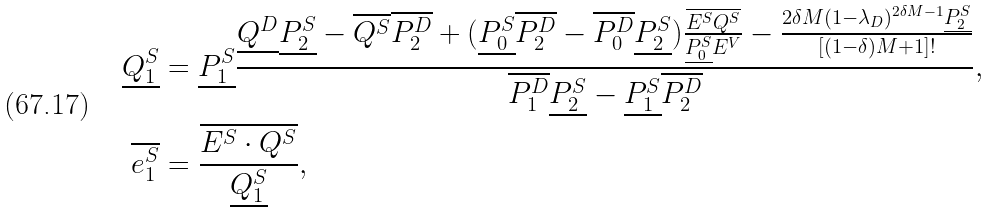Convert formula to latex. <formula><loc_0><loc_0><loc_500><loc_500>\underline { Q _ { 1 } ^ { S } } & = \underline { P _ { 1 } ^ { S } } \frac { \underline { Q ^ { D } } \underline { P _ { 2 } ^ { S } } - \overline { Q ^ { S } } \overline { P _ { 2 } ^ { D } } + ( \underline { P _ { 0 } ^ { S } } \overline { P _ { 2 } ^ { D } } - \overline { P _ { 0 } ^ { D } } \underline { P _ { 2 } ^ { S } } ) \frac { \overline { E ^ { S } Q ^ { S } } } { \underline { P _ { 0 } ^ { S } } E ^ { V } } - \frac { 2 \delta M ( 1 - \lambda _ { D } ) ^ { 2 \delta M - 1 } \underline { P _ { 2 } ^ { S } } } { [ ( 1 - \delta ) M + 1 ] ! } } { \overline { P _ { 1 } ^ { D } } \underline { P _ { 2 } ^ { S } } - \underline { P _ { 1 } ^ { S } } \overline { P _ { 2 } ^ { D } } } , \\ \overline { e _ { 1 } ^ { S } } & = \frac { \overline { E ^ { S } \cdot Q ^ { S } } } { \underline { Q _ { 1 } ^ { S } } } ,</formula> 